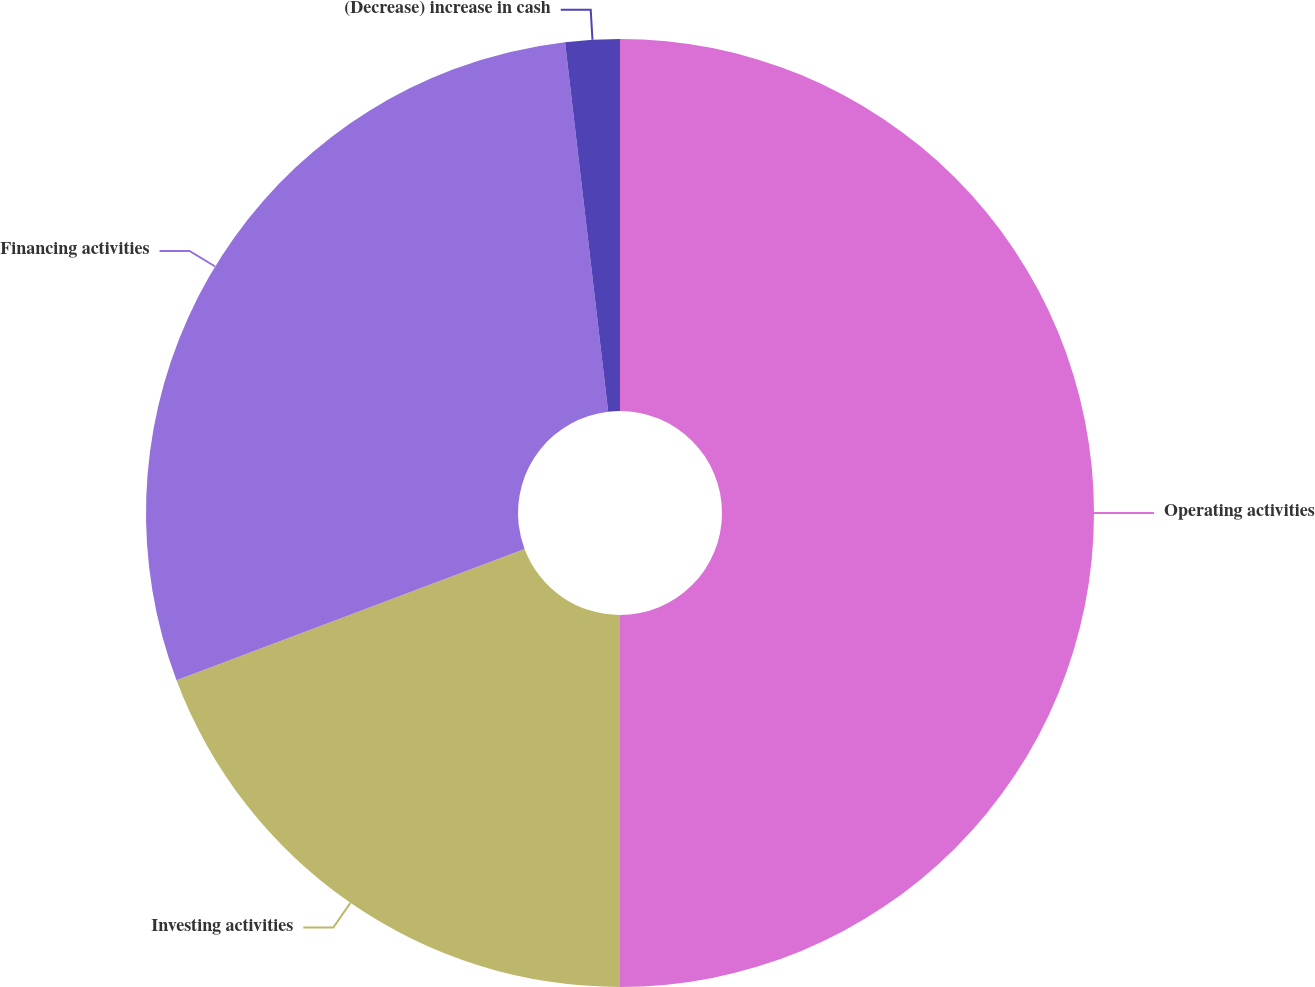Convert chart to OTSL. <chart><loc_0><loc_0><loc_500><loc_500><pie_chart><fcel>Operating activities<fcel>Investing activities<fcel>Financing activities<fcel>(Decrease) increase in cash<nl><fcel>50.0%<fcel>19.26%<fcel>28.89%<fcel>1.85%<nl></chart> 